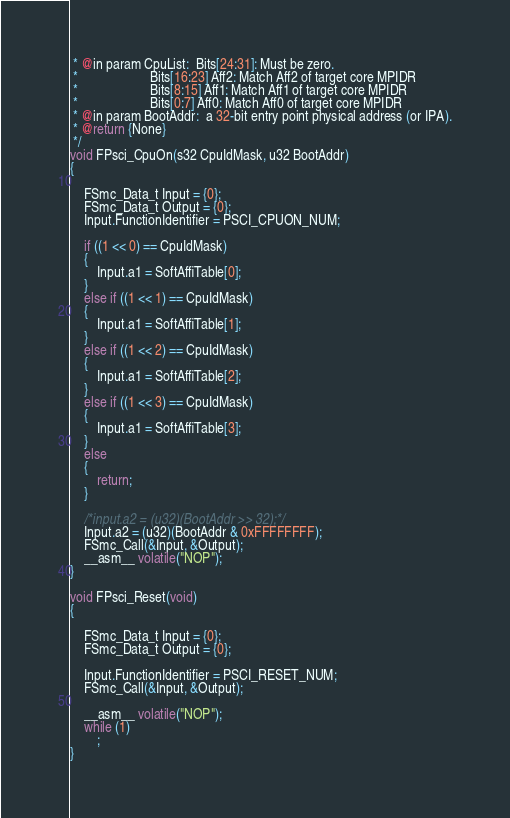Convert code to text. <code><loc_0><loc_0><loc_500><loc_500><_C_> * @in param CpuList:  Bits[24:31]: Must be zero.
 *                     Bits[16:23] Aff2: Match Aff2 of target core MPIDR
 *                     Bits[8:15] Aff1: Match Aff1 of target core MPIDR
 *                     Bits[0:7] Aff0: Match Aff0 of target core MPIDR
 * @in param BootAddr:  a 32-bit entry point physical address (or IPA).
 * @return {None}
 */
void FPsci_CpuOn(s32 CpuIdMask, u32 BootAddr)
{

    FSmc_Data_t Input = {0};
    FSmc_Data_t Output = {0};
    Input.FunctionIdentifier = PSCI_CPUON_NUM;

    if ((1 << 0) == CpuIdMask)
    {
        Input.a1 = SoftAffiTable[0];
    }
    else if ((1 << 1) == CpuIdMask)
    {
        Input.a1 = SoftAffiTable[1];
    }
    else if ((1 << 2) == CpuIdMask)
    {
        Input.a1 = SoftAffiTable[2];
    }
    else if ((1 << 3) == CpuIdMask)
    {
        Input.a1 = SoftAffiTable[3];
    }
    else
    {
        return;
    }

    /*input.a2 = (u32)(BootAddr >> 32);*/
    Input.a2 = (u32)(BootAddr & 0xFFFFFFFF);
    FSmc_Call(&Input, &Output);
    __asm__ volatile("NOP");
}

void FPsci_Reset(void)
{

    FSmc_Data_t Input = {0};
    FSmc_Data_t Output = {0};

    Input.FunctionIdentifier = PSCI_RESET_NUM;
    FSmc_Call(&Input, &Output);

    __asm__ volatile("NOP");
    while (1)
        ;
}
</code> 